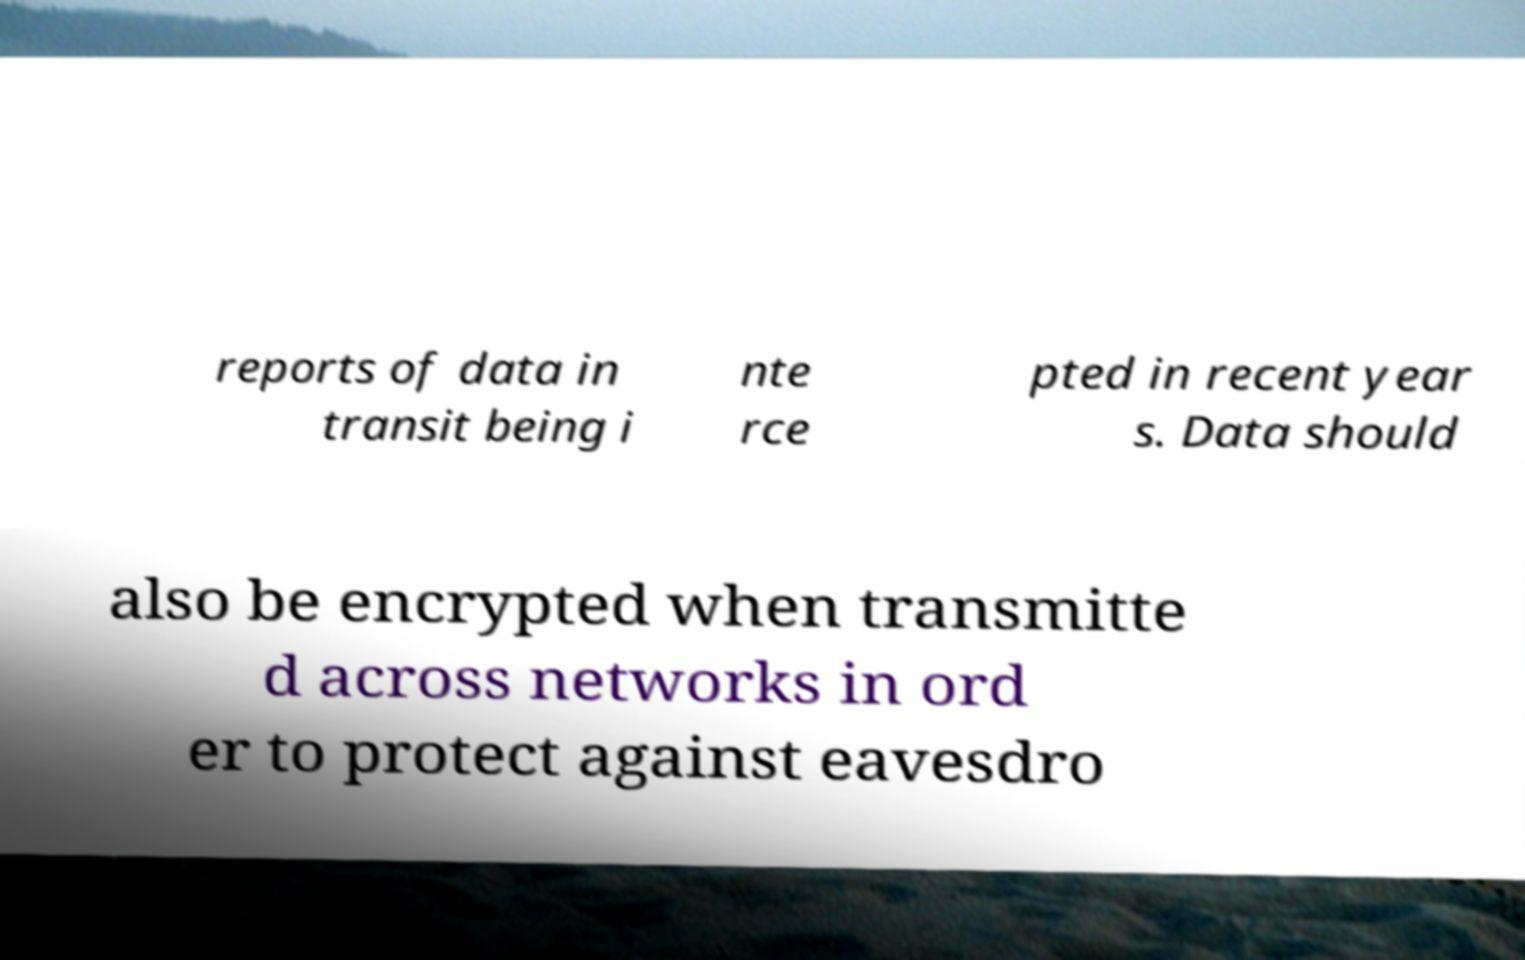Please read and relay the text visible in this image. What does it say? reports of data in transit being i nte rce pted in recent year s. Data should also be encrypted when transmitte d across networks in ord er to protect against eavesdro 